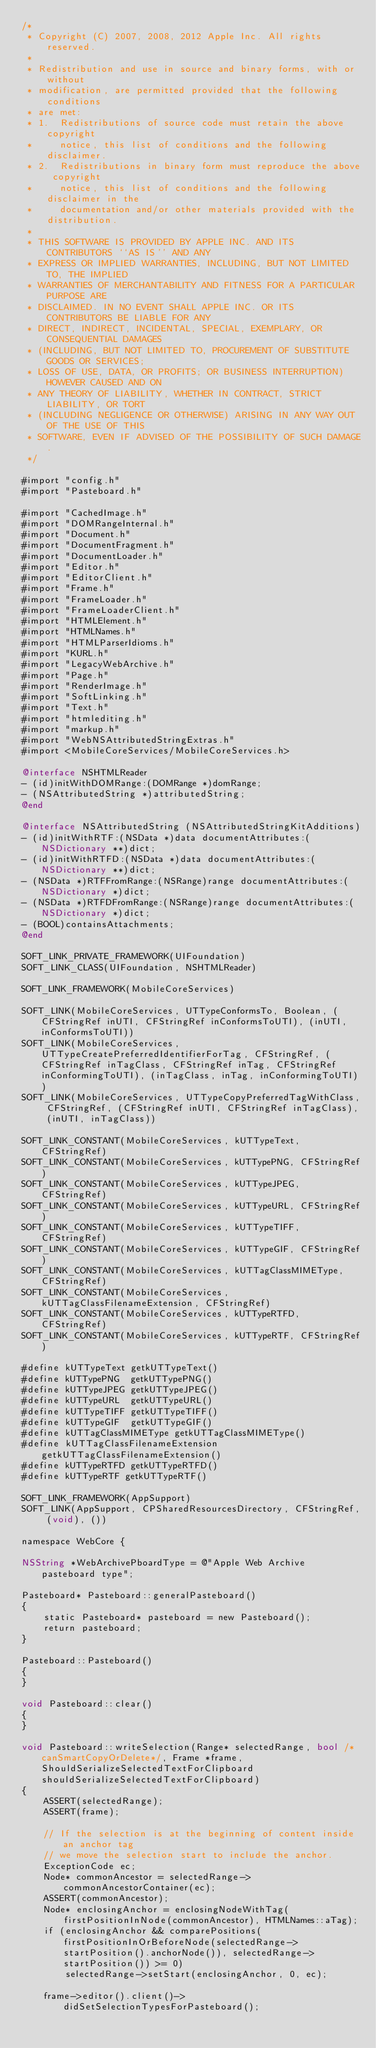<code> <loc_0><loc_0><loc_500><loc_500><_ObjectiveC_>/*
 * Copyright (C) 2007, 2008, 2012 Apple Inc. All rights reserved.
 *
 * Redistribution and use in source and binary forms, with or without
 * modification, are permitted provided that the following conditions
 * are met:
 * 1.  Redistributions of source code must retain the above copyright
 *     notice, this list of conditions and the following disclaimer.
 * 2.  Redistributions in binary form must reproduce the above copyright
 *     notice, this list of conditions and the following disclaimer in the
 *     documentation and/or other materials provided with the distribution.
 *
 * THIS SOFTWARE IS PROVIDED BY APPLE INC. AND ITS CONTRIBUTORS ``AS IS'' AND ANY
 * EXPRESS OR IMPLIED WARRANTIES, INCLUDING, BUT NOT LIMITED TO, THE IMPLIED
 * WARRANTIES OF MERCHANTABILITY AND FITNESS FOR A PARTICULAR PURPOSE ARE
 * DISCLAIMED. IN NO EVENT SHALL APPLE INC. OR ITS CONTRIBUTORS BE LIABLE FOR ANY
 * DIRECT, INDIRECT, INCIDENTAL, SPECIAL, EXEMPLARY, OR CONSEQUENTIAL DAMAGES
 * (INCLUDING, BUT NOT LIMITED TO, PROCUREMENT OF SUBSTITUTE GOODS OR SERVICES;
 * LOSS OF USE, DATA, OR PROFITS; OR BUSINESS INTERRUPTION) HOWEVER CAUSED AND ON
 * ANY THEORY OF LIABILITY, WHETHER IN CONTRACT, STRICT LIABILITY, OR TORT
 * (INCLUDING NEGLIGENCE OR OTHERWISE) ARISING IN ANY WAY OUT OF THE USE OF THIS
 * SOFTWARE, EVEN IF ADVISED OF THE POSSIBILITY OF SUCH DAMAGE.
 */

#import "config.h"
#import "Pasteboard.h"

#import "CachedImage.h"
#import "DOMRangeInternal.h"
#import "Document.h"
#import "DocumentFragment.h"
#import "DocumentLoader.h"
#import "Editor.h"
#import "EditorClient.h"
#import "Frame.h"
#import "FrameLoader.h"
#import "FrameLoaderClient.h"
#import "HTMLElement.h"
#import "HTMLNames.h"
#import "HTMLParserIdioms.h"
#import "KURL.h"
#import "LegacyWebArchive.h"
#import "Page.h"
#import "RenderImage.h"
#import "SoftLinking.h"
#import "Text.h"
#import "htmlediting.h"
#import "markup.h"
#import "WebNSAttributedStringExtras.h"
#import <MobileCoreServices/MobileCoreServices.h>

@interface NSHTMLReader
- (id)initWithDOMRange:(DOMRange *)domRange;
- (NSAttributedString *)attributedString;
@end

@interface NSAttributedString (NSAttributedStringKitAdditions)
- (id)initWithRTF:(NSData *)data documentAttributes:(NSDictionary **)dict;
- (id)initWithRTFD:(NSData *)data documentAttributes:(NSDictionary **)dict;
- (NSData *)RTFFromRange:(NSRange)range documentAttributes:(NSDictionary *)dict;
- (NSData *)RTFDFromRange:(NSRange)range documentAttributes:(NSDictionary *)dict;
- (BOOL)containsAttachments;
@end

SOFT_LINK_PRIVATE_FRAMEWORK(UIFoundation)
SOFT_LINK_CLASS(UIFoundation, NSHTMLReader)

SOFT_LINK_FRAMEWORK(MobileCoreServices)

SOFT_LINK(MobileCoreServices, UTTypeConformsTo, Boolean, (CFStringRef inUTI, CFStringRef inConformsToUTI), (inUTI, inConformsToUTI))
SOFT_LINK(MobileCoreServices, UTTypeCreatePreferredIdentifierForTag, CFStringRef, (CFStringRef inTagClass, CFStringRef inTag, CFStringRef inConformingToUTI), (inTagClass, inTag, inConformingToUTI))
SOFT_LINK(MobileCoreServices, UTTypeCopyPreferredTagWithClass, CFStringRef, (CFStringRef inUTI, CFStringRef inTagClass), (inUTI, inTagClass))

SOFT_LINK_CONSTANT(MobileCoreServices, kUTTypeText, CFStringRef)
SOFT_LINK_CONSTANT(MobileCoreServices, kUTTypePNG, CFStringRef)
SOFT_LINK_CONSTANT(MobileCoreServices, kUTTypeJPEG, CFStringRef)
SOFT_LINK_CONSTANT(MobileCoreServices, kUTTypeURL, CFStringRef)
SOFT_LINK_CONSTANT(MobileCoreServices, kUTTypeTIFF, CFStringRef)
SOFT_LINK_CONSTANT(MobileCoreServices, kUTTypeGIF, CFStringRef)
SOFT_LINK_CONSTANT(MobileCoreServices, kUTTagClassMIMEType, CFStringRef)
SOFT_LINK_CONSTANT(MobileCoreServices, kUTTagClassFilenameExtension, CFStringRef)
SOFT_LINK_CONSTANT(MobileCoreServices, kUTTypeRTFD, CFStringRef)
SOFT_LINK_CONSTANT(MobileCoreServices, kUTTypeRTF, CFStringRef)

#define kUTTypeText getkUTTypeText()
#define kUTTypePNG  getkUTTypePNG()
#define kUTTypeJPEG getkUTTypeJPEG()
#define kUTTypeURL  getkUTTypeURL()
#define kUTTypeTIFF getkUTTypeTIFF()
#define kUTTypeGIF  getkUTTypeGIF()
#define kUTTagClassMIMEType getkUTTagClassMIMEType()
#define kUTTagClassFilenameExtension getkUTTagClassFilenameExtension()
#define kUTTypeRTFD getkUTTypeRTFD()
#define kUTTypeRTF getkUTTypeRTF()

SOFT_LINK_FRAMEWORK(AppSupport)
SOFT_LINK(AppSupport, CPSharedResourcesDirectory, CFStringRef, (void), ())

namespace WebCore {

NSString *WebArchivePboardType = @"Apple Web Archive pasteboard type";

Pasteboard* Pasteboard::generalPasteboard()
{
    static Pasteboard* pasteboard = new Pasteboard();
    return pasteboard;
}

Pasteboard::Pasteboard()
{
}

void Pasteboard::clear()
{
}

void Pasteboard::writeSelection(Range* selectedRange, bool /*canSmartCopyOrDelete*/, Frame *frame, ShouldSerializeSelectedTextForClipboard shouldSerializeSelectedTextForClipboard)
{
    ASSERT(selectedRange);
    ASSERT(frame);

    // If the selection is at the beginning of content inside an anchor tag
    // we move the selection start to include the anchor.
    ExceptionCode ec;
    Node* commonAncestor = selectedRange->commonAncestorContainer(ec);
    ASSERT(commonAncestor);
    Node* enclosingAnchor = enclosingNodeWithTag(firstPositionInNode(commonAncestor), HTMLNames::aTag);
    if (enclosingAnchor && comparePositions(firstPositionInOrBeforeNode(selectedRange->startPosition().anchorNode()), selectedRange->startPosition()) >= 0)
        selectedRange->setStart(enclosingAnchor, 0, ec);

    frame->editor().client()->didSetSelectionTypesForPasteboard();
</code> 